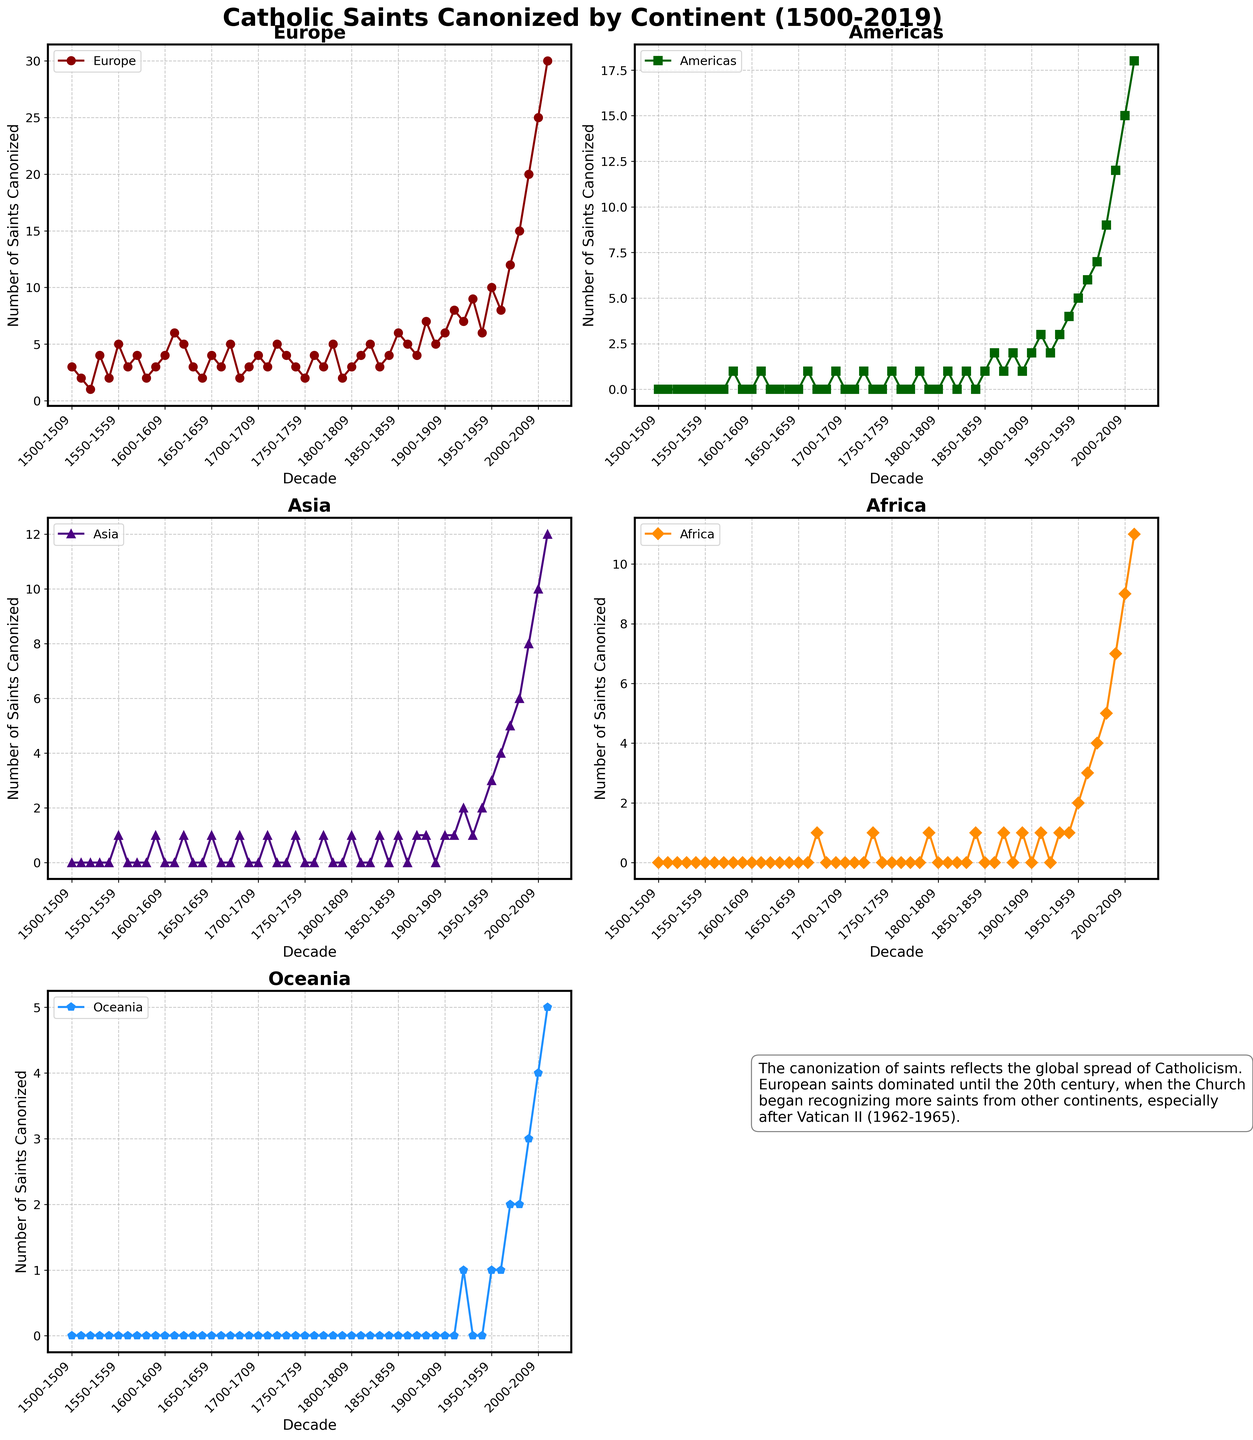What is the title of the figure? The title of the figure is mentioned at the top center of the plot. It reads "Catholic Saints Canonized by Continent (1500-2019)".
Answer: Catholic Saints Canonized by Continent (1500-2019) Which continent has the highest number of saints canonized in the decade 2010-2019? For the decade 2010-2019, the subplot depicting data for each continent shows the number of saints canonized. It is visible that Europe has the highest number (30).
Answer: Europe How many saints from Africa were canonized in the decade 1970-1979? The subplot titled "Africa" indicates the number of saints canonized in each decade. For 1970-1979, the plot shows 4 saints.
Answer: 4 In which decade did Oceania see its first saint canonized? By observing the subplot for Oceania, we can see that the first appearance of saints canonized is in the 1920-1929 decade with one saint.
Answer: 1920-1929 How does the number of saints canonized from Asia in the 1950-1959 decade compare to the number canonized from Africa in the same decade? The subplot for Asia shows 3 saints canonized in the 1950-1959 decade, while the subplot for Africa shows 2 saints canonized in the same period. Therefore, Asia had one more saint canonized than Africa in that decade.
Answer: Asia had more By how much did the number of saints canonized from the Americas increase from the 1940s to the 1950s? The subplot for the Americas indicates 4 saints canonized in the 1940-1949 decade and 5 saints in the 1950-1959 decade. The difference is 5 - 4 = 1.
Answer: increased by 1 What trend is observed in the number of saints canonized from Europe over the centuries? The subplot for Europe shows a general upward trend, with a significant increase starting in the 20th century, reaching its highest in the 2010-2019 decade.
Answer: Increasing trend In which decade do all continents combined see the highest number of canonized saints? Summing up the number of canonized saints for all continents in each subplot, the 2010-2019 decade has the highest combined number. Europe: 30, Americas: 18, Asia: 12, Africa: 11, Oceania: 5; total: 76.
Answer: 2010-2019 Which continent shows a notable increase in the number of saints canonized starting around the 20th century? Observing the plots, the Americas show a noticeable increase in the number of saints starting from the early 20th century.
Answer: Americas What explanatory text is provided in the figure? There is a text box with historical context explaining the global spread of Catholicism and the significant increase in the number of canonized saints from other continents, especially after Vatican II (1962-1965).
Answer: Explanation of the global spread of Catholicism and reference to Vatican II 